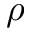<formula> <loc_0><loc_0><loc_500><loc_500>\rho</formula> 